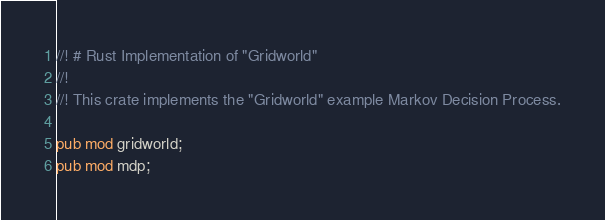Convert code to text. <code><loc_0><loc_0><loc_500><loc_500><_Rust_>//! # Rust Implementation of "Gridworld"
//!
//! This crate implements the "Gridworld" example Markov Decision Process.

pub mod gridworld;
pub mod mdp;
</code> 